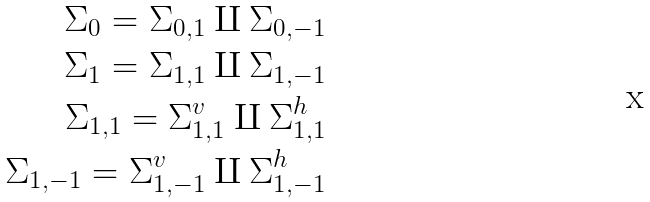<formula> <loc_0><loc_0><loc_500><loc_500>\Sigma _ { 0 } = \Sigma _ { 0 , 1 } \amalg \Sigma _ { 0 , - 1 } \\ \Sigma _ { 1 } = \Sigma _ { 1 , 1 } \amalg \Sigma _ { 1 , - 1 } \\ \Sigma _ { 1 , 1 } = \Sigma _ { 1 , 1 } ^ { v } \amalg \Sigma _ { 1 , 1 } ^ { h } \\ \Sigma _ { 1 , - 1 } = \Sigma _ { 1 , - 1 } ^ { v } \amalg \Sigma _ { 1 , - 1 } ^ { h }</formula> 